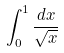Convert formula to latex. <formula><loc_0><loc_0><loc_500><loc_500>\int _ { 0 } ^ { 1 } \frac { d x } { \sqrt { x } }</formula> 